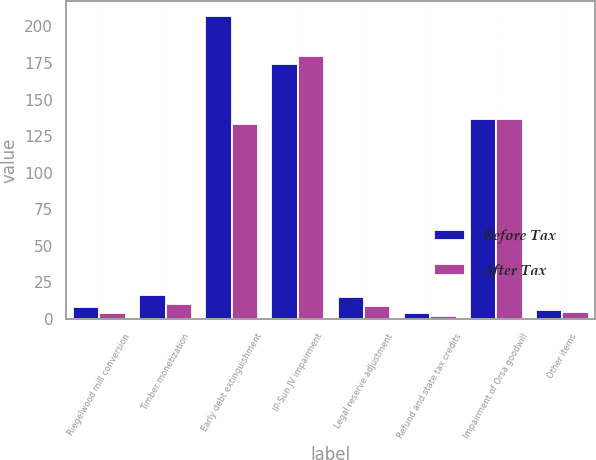Convert chart. <chart><loc_0><loc_0><loc_500><loc_500><stacked_bar_chart><ecel><fcel>Riegelwood mill conversion<fcel>Timber monetization<fcel>Early debt extinguishment<fcel>IP-Sun JV impairment<fcel>Legal reserve adjustment<fcel>Refund and state tax credits<fcel>Impairment of Orsa goodwill<fcel>Other items<nl><fcel>Before Tax<fcel>8<fcel>16<fcel>207<fcel>174<fcel>15<fcel>4<fcel>137<fcel>6<nl><fcel>After Tax<fcel>4<fcel>10<fcel>133<fcel>180<fcel>9<fcel>2<fcel>137<fcel>5<nl></chart> 